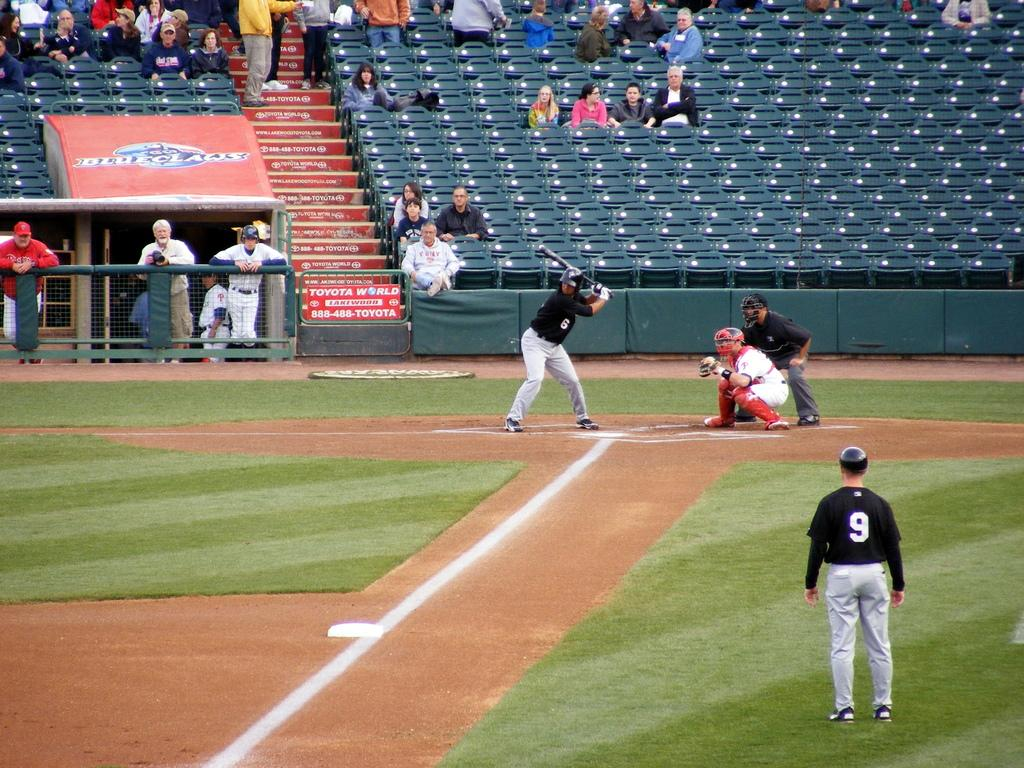<image>
Provide a brief description of the given image. Daytime baseball game which is sponsored by Toyota World. 